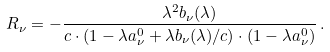<formula> <loc_0><loc_0><loc_500><loc_500>R _ { \nu } = - \frac { \lambda ^ { 2 } b _ { \nu } ( \lambda ) } { c \cdot ( 1 - \lambda a _ { \nu } ^ { 0 } + \lambda b _ { \nu } ( \lambda ) / c ) \cdot ( 1 - \lambda a _ { \nu } ^ { 0 } ) } \, .</formula> 